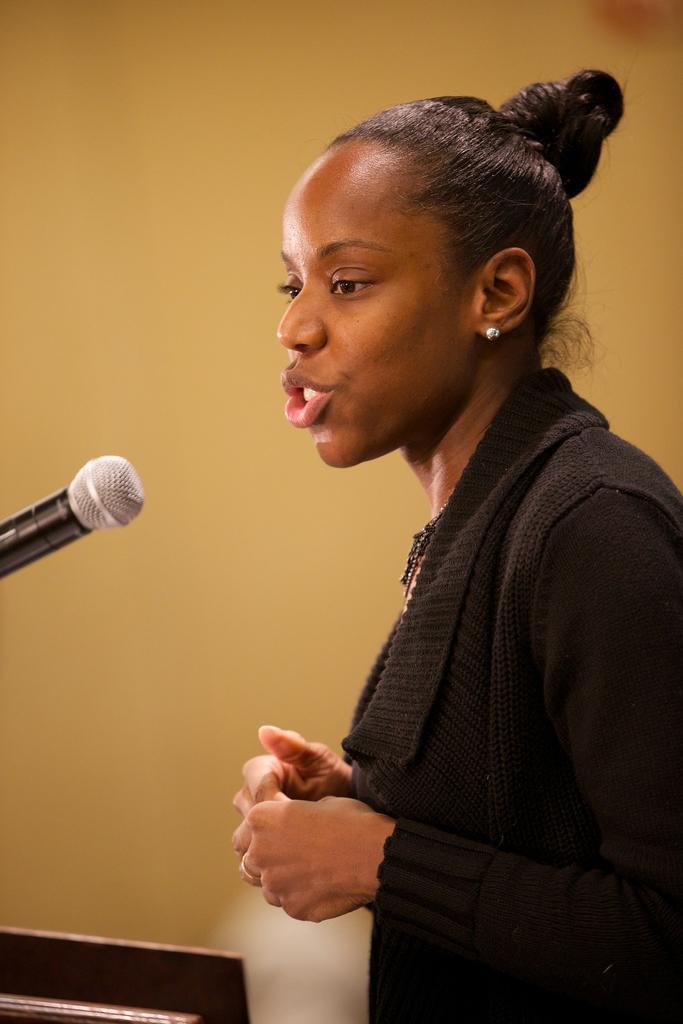In one or two sentences, can you explain what this image depicts? In this image there is a girl standing in front of the mic. In the background there is a wall. 